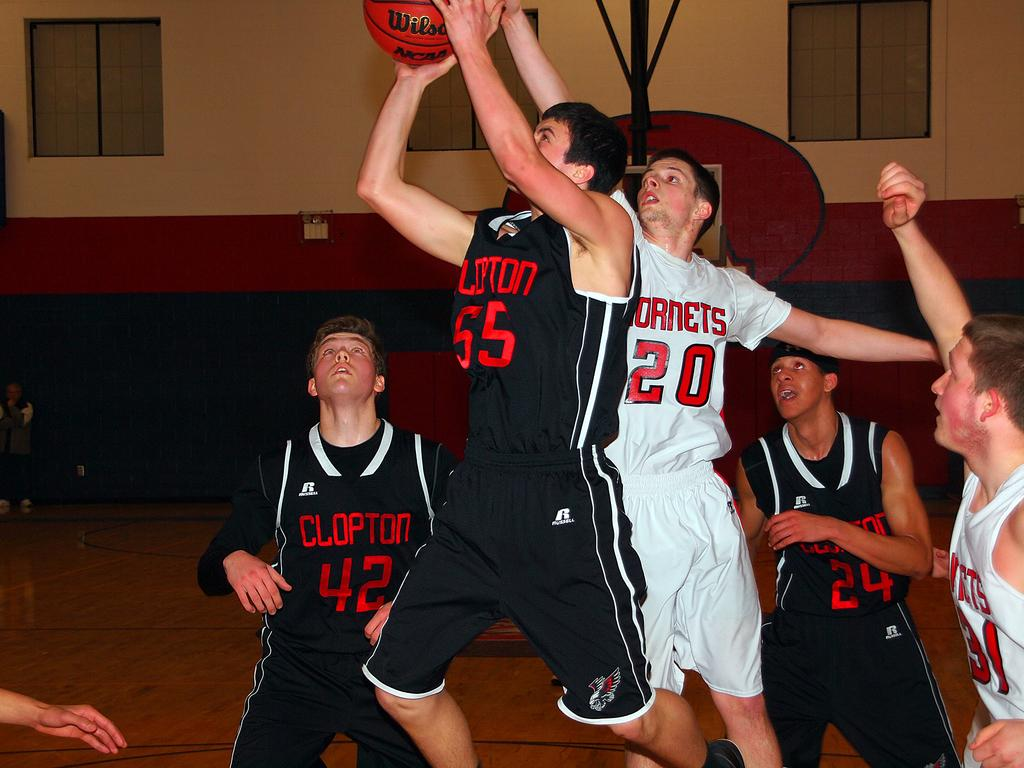What are the boys in the image doing? The boys are playing basketball. What can be seen on the wall in the image? There are windows on the wall in the image. What book are the boys reading during their basketball game? There is no book present in the image, as the boys are playing basketball and not reading. 